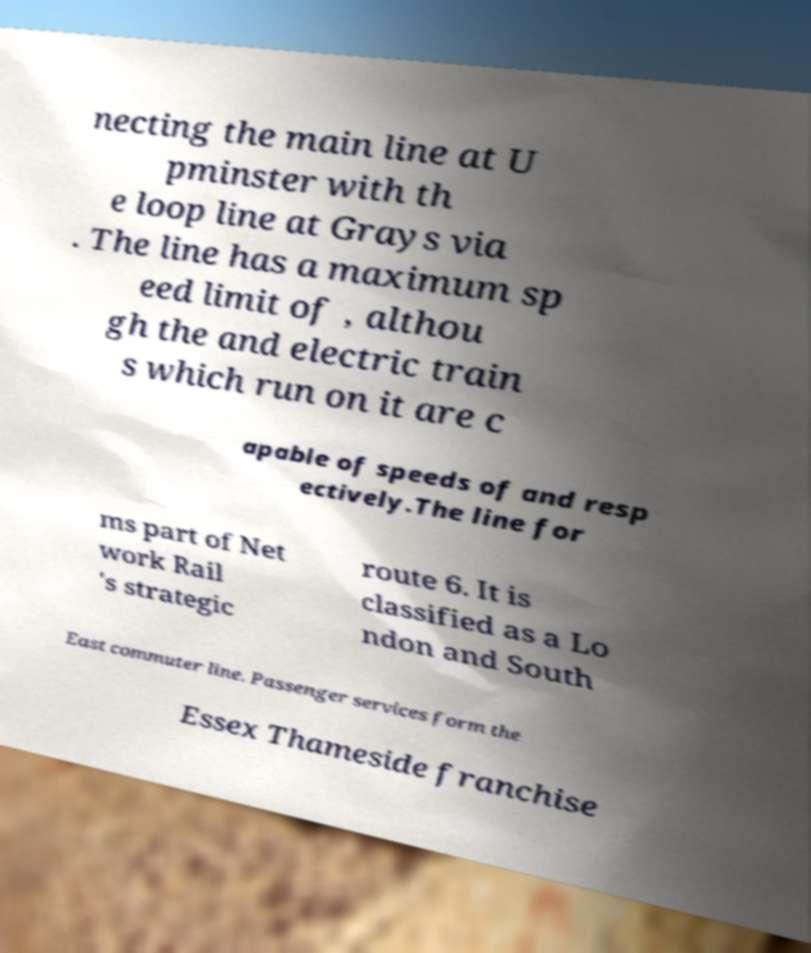Can you read and provide the text displayed in the image?This photo seems to have some interesting text. Can you extract and type it out for me? necting the main line at U pminster with th e loop line at Grays via . The line has a maximum sp eed limit of , althou gh the and electric train s which run on it are c apable of speeds of and resp ectively.The line for ms part of Net work Rail 's strategic route 6. It is classified as a Lo ndon and South East commuter line. Passenger services form the Essex Thameside franchise 